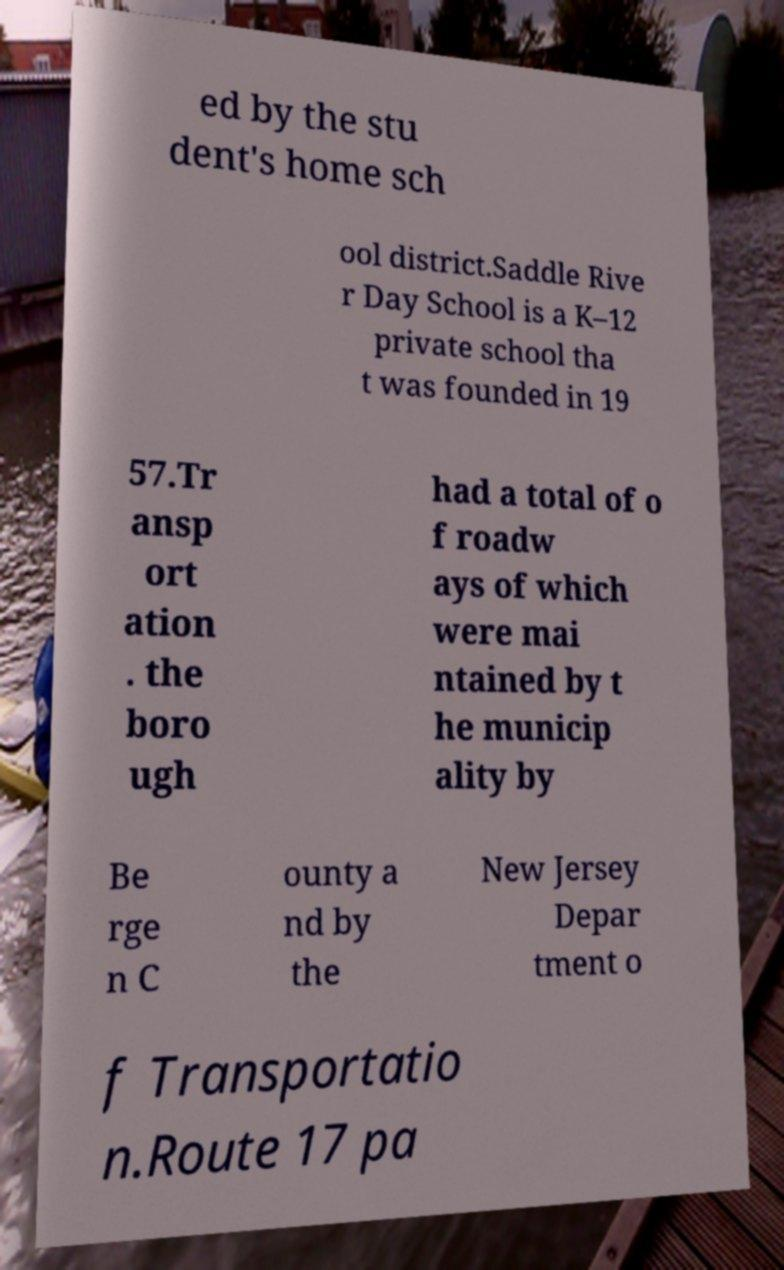Could you extract and type out the text from this image? ed by the stu dent's home sch ool district.Saddle Rive r Day School is a K–12 private school tha t was founded in 19 57.Tr ansp ort ation . the boro ugh had a total of o f roadw ays of which were mai ntained by t he municip ality by Be rge n C ounty a nd by the New Jersey Depar tment o f Transportatio n.Route 17 pa 